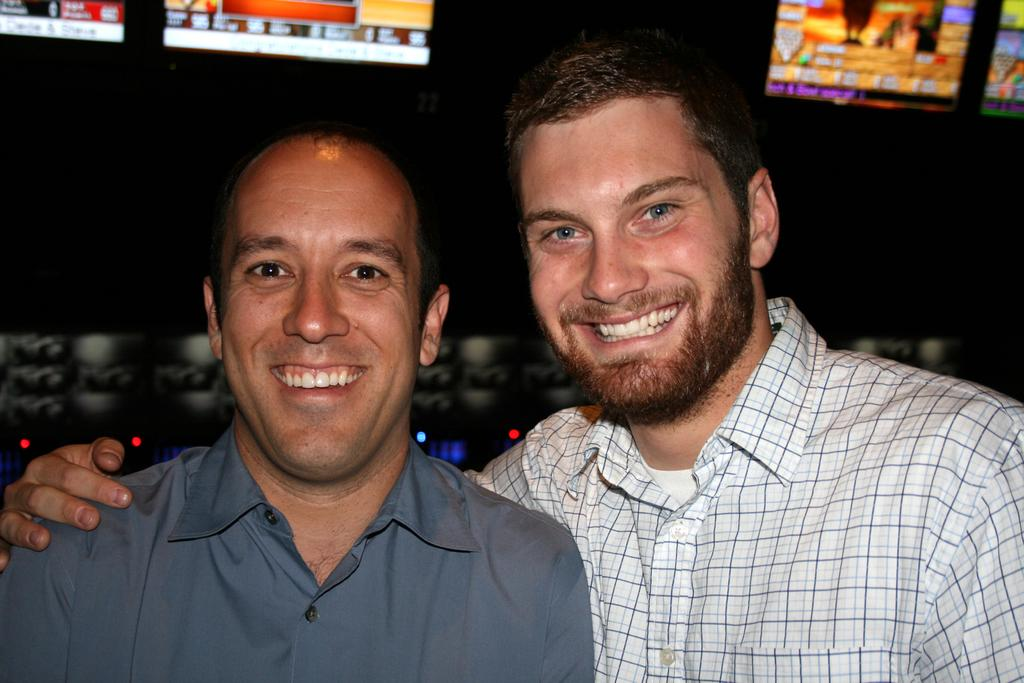How many people are in the image? There are two persons in the image. What are the two persons doing in the image? The two persons are standing. What expressions do the two persons have in the image? The two persons are smiling. What objects are visible in the image besides the two persons? There are screens visible in the image. What hobbies do the two persons regret not pursuing in the image? There is no indication in the image that the two persons have any regrets or hobbies they regret not pursuing. Is there an umbrella visible in the image? There is no umbrella present in the image. 